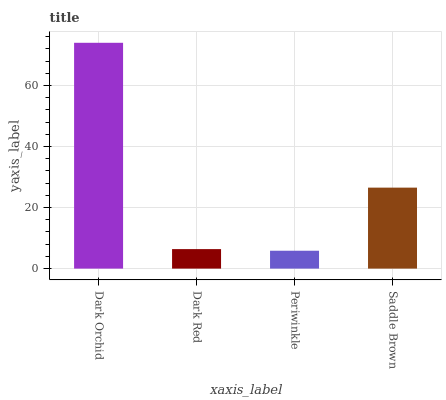Is Periwinkle the minimum?
Answer yes or no. Yes. Is Dark Orchid the maximum?
Answer yes or no. Yes. Is Dark Red the minimum?
Answer yes or no. No. Is Dark Red the maximum?
Answer yes or no. No. Is Dark Orchid greater than Dark Red?
Answer yes or no. Yes. Is Dark Red less than Dark Orchid?
Answer yes or no. Yes. Is Dark Red greater than Dark Orchid?
Answer yes or no. No. Is Dark Orchid less than Dark Red?
Answer yes or no. No. Is Saddle Brown the high median?
Answer yes or no. Yes. Is Dark Red the low median?
Answer yes or no. Yes. Is Dark Orchid the high median?
Answer yes or no. No. Is Saddle Brown the low median?
Answer yes or no. No. 